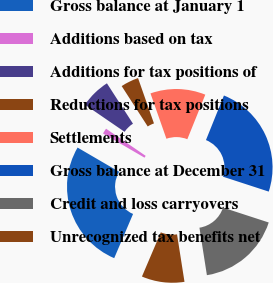<chart> <loc_0><loc_0><loc_500><loc_500><pie_chart><fcel>Gross balance at January 1<fcel>Additions based on tax<fcel>Additions for tax positions of<fcel>Reductions for tax positions<fcel>Settlements<fcel>Gross balance at December 31<fcel>Credit and loss carryovers<fcel>Unrecognized tax benefits net<nl><fcel>26.98%<fcel>1.16%<fcel>6.32%<fcel>3.74%<fcel>11.48%<fcel>23.91%<fcel>17.51%<fcel>8.9%<nl></chart> 